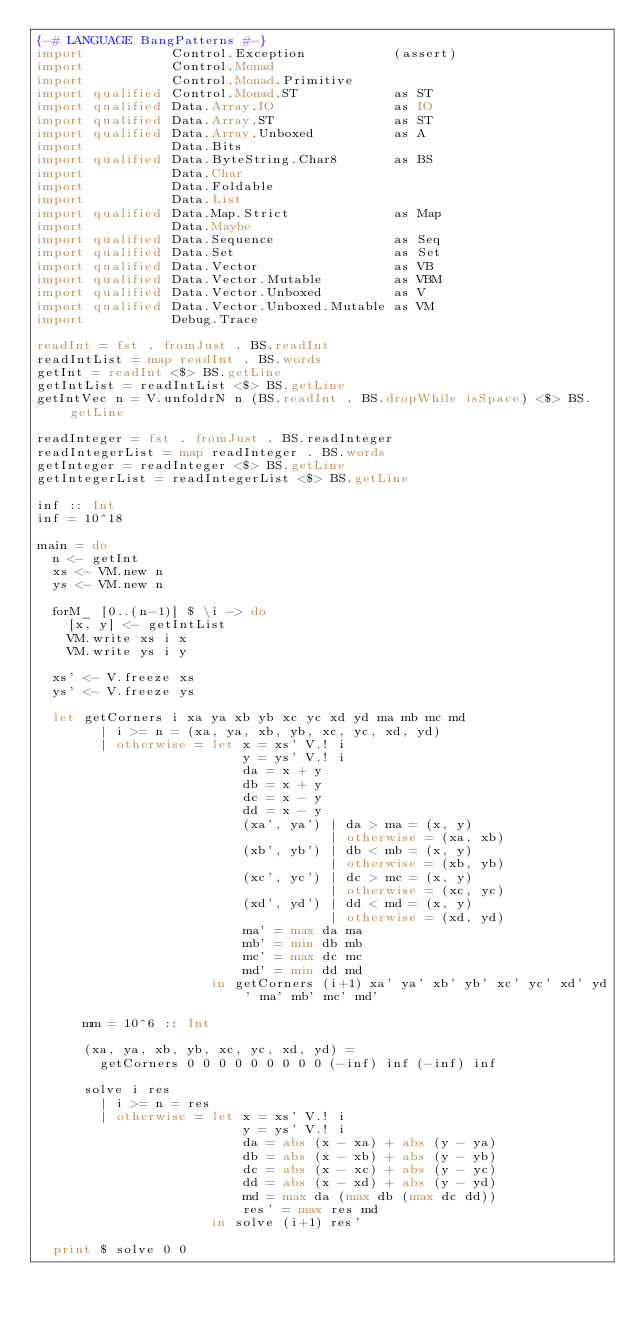<code> <loc_0><loc_0><loc_500><loc_500><_Haskell_>{-# LANGUAGE BangPatterns #-}
import           Control.Exception           (assert)
import           Control.Monad
import           Control.Monad.Primitive
import qualified Control.Monad.ST            as ST
import qualified Data.Array.IO               as IO
import qualified Data.Array.ST               as ST
import qualified Data.Array.Unboxed          as A
import           Data.Bits
import qualified Data.ByteString.Char8       as BS
import           Data.Char
import           Data.Foldable
import           Data.List
import qualified Data.Map.Strict             as Map
import           Data.Maybe
import qualified Data.Sequence               as Seq
import qualified Data.Set                    as Set
import qualified Data.Vector                 as VB
import qualified Data.Vector.Mutable         as VBM
import qualified Data.Vector.Unboxed         as V
import qualified Data.Vector.Unboxed.Mutable as VM
import           Debug.Trace

readInt = fst . fromJust . BS.readInt
readIntList = map readInt . BS.words
getInt = readInt <$> BS.getLine
getIntList = readIntList <$> BS.getLine
getIntVec n = V.unfoldrN n (BS.readInt . BS.dropWhile isSpace) <$> BS.getLine

readInteger = fst . fromJust . BS.readInteger
readIntegerList = map readInteger . BS.words
getInteger = readInteger <$> BS.getLine
getIntegerList = readIntegerList <$> BS.getLine

inf :: Int
inf = 10^18

main = do
  n <- getInt
  xs <- VM.new n
  ys <- VM.new n

  forM_ [0..(n-1)] $ \i -> do
    [x, y] <- getIntList
    VM.write xs i x
    VM.write ys i y

  xs' <- V.freeze xs
  ys' <- V.freeze ys

  let getCorners i xa ya xb yb xc yc xd yd ma mb mc md
        | i >= n = (xa, ya, xb, yb, xc, yc, xd, yd)
        | otherwise = let x = xs' V.! i
                          y = ys' V.! i
                          da = x + y
                          db = x + y
                          dc = x - y
                          dd = x - y
                          (xa', ya') | da > ma = (x, y)
                                     | otherwise = (xa, xb)
                          (xb', yb') | db < mb = (x, y)
                                     | otherwise = (xb, yb)
                          (xc', yc') | dc > mc = (x, y)
                                     | otherwise = (xc, yc)
                          (xd', yd') | dd < md = (x, y)
                                     | otherwise = (xd, yd)
                          ma' = max da ma
                          mb' = min db mb
                          mc' = max dc mc
                          md' = min dd md
                      in getCorners (i+1) xa' ya' xb' yb' xc' yc' xd' yd' ma' mb' mc' md'

      mm = 10^6 :: Int

      (xa, ya, xb, yb, xc, yc, xd, yd) =
        getCorners 0 0 0 0 0 0 0 0 0 (-inf) inf (-inf) inf

      solve i res
        | i >= n = res
        | otherwise = let x = xs' V.! i
                          y = ys' V.! i
                          da = abs (x - xa) + abs (y - ya)
                          db = abs (x - xb) + abs (y - yb)
                          dc = abs (x - xc) + abs (y - yc)
                          dd = abs (x - xd) + abs (y - yd)
                          md = max da (max db (max dc dd))
                          res' = max res md
                      in solve (i+1) res'

  print $ solve 0 0
</code> 